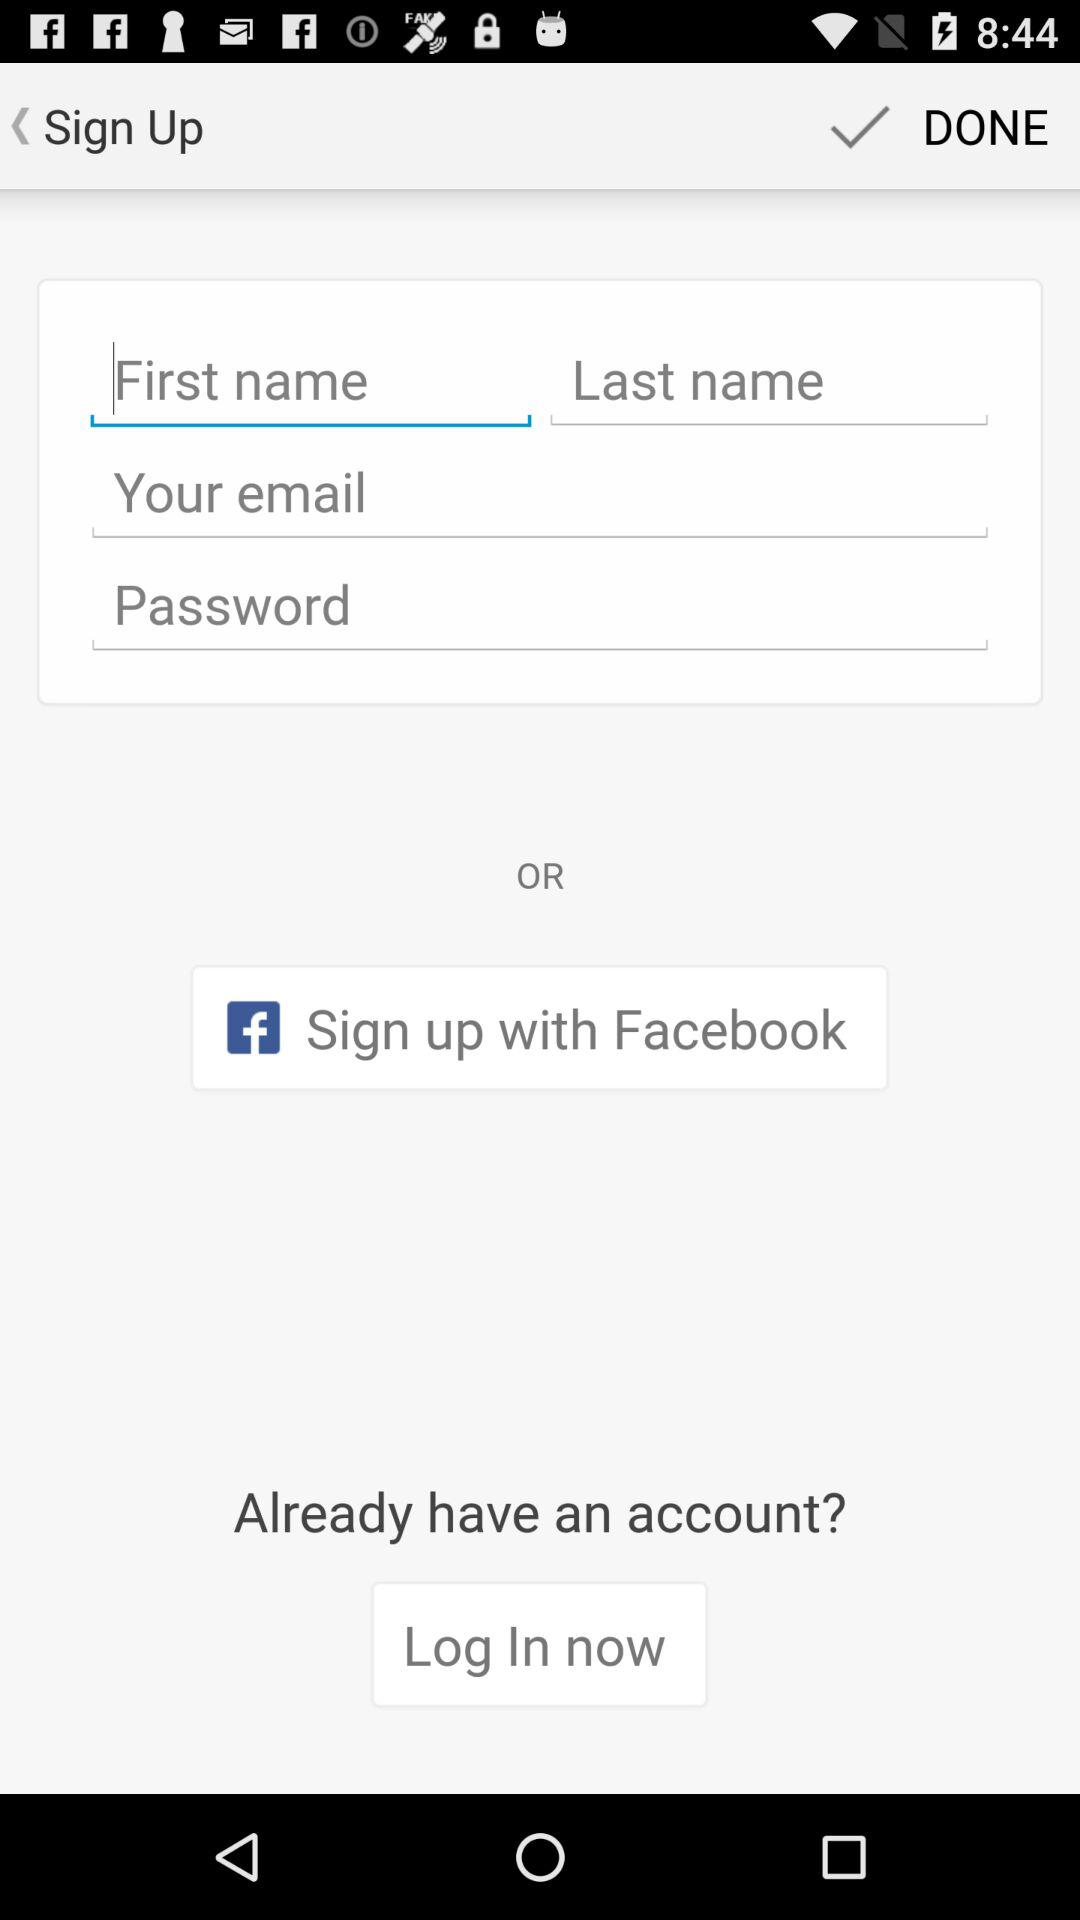What account to continue with? You can continue with "Facebook". 